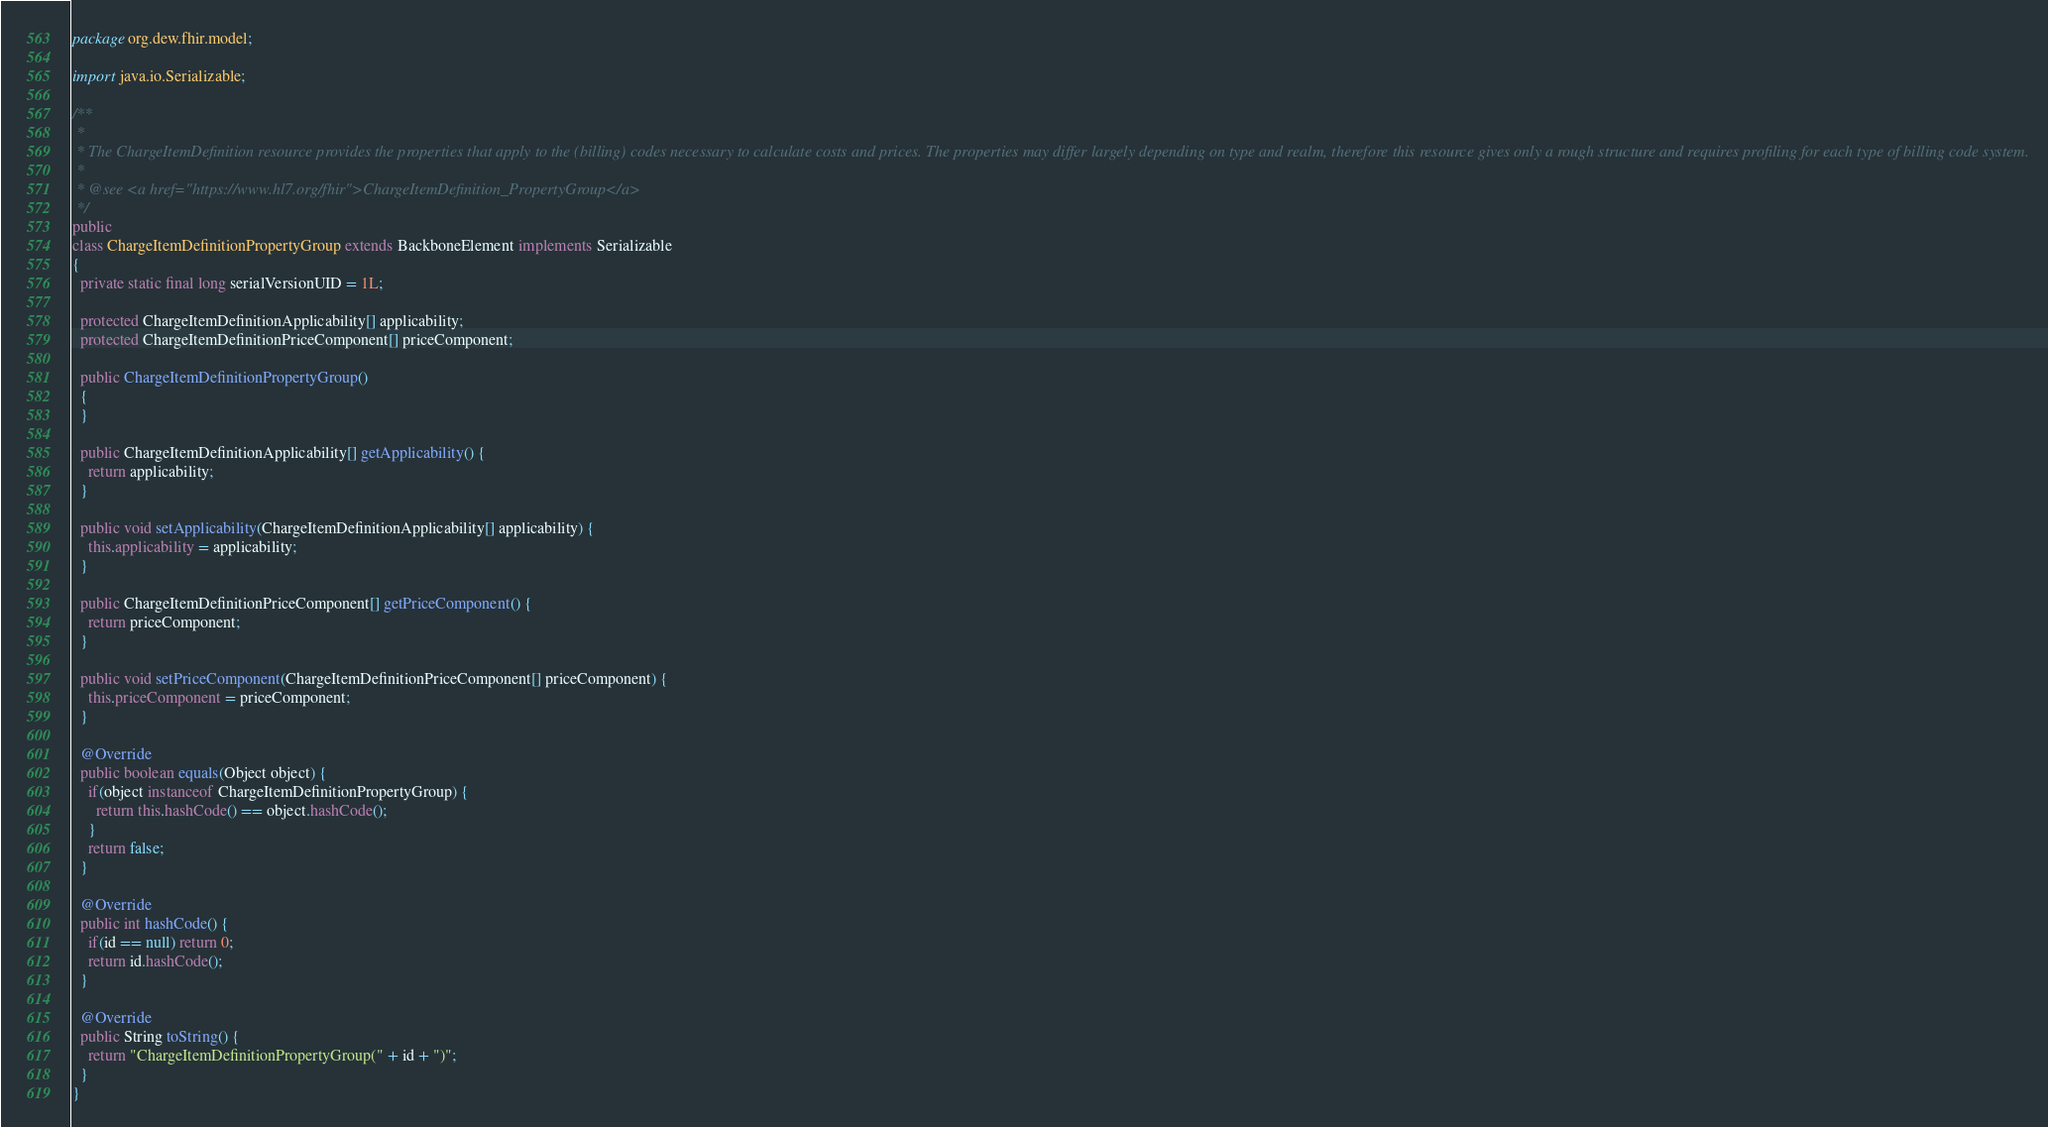<code> <loc_0><loc_0><loc_500><loc_500><_Java_>package org.dew.fhir.model;

import java.io.Serializable;

/**
 *
 * The ChargeItemDefinition resource provides the properties that apply to the (billing) codes necessary to calculate costs and prices. The properties may differ largely depending on type and realm, therefore this resource gives only a rough structure and requires profiling for each type of billing code system.
 *
 * @see <a href="https://www.hl7.org/fhir">ChargeItemDefinition_PropertyGroup</a>
 */
public
class ChargeItemDefinitionPropertyGroup extends BackboneElement implements Serializable
{
  private static final long serialVersionUID = 1L;
  
  protected ChargeItemDefinitionApplicability[] applicability;
  protected ChargeItemDefinitionPriceComponent[] priceComponent;
  
  public ChargeItemDefinitionPropertyGroup()
  {
  }
  
  public ChargeItemDefinitionApplicability[] getApplicability() {
    return applicability;
  }
  
  public void setApplicability(ChargeItemDefinitionApplicability[] applicability) {
    this.applicability = applicability;
  }
  
  public ChargeItemDefinitionPriceComponent[] getPriceComponent() {
    return priceComponent;
  }
  
  public void setPriceComponent(ChargeItemDefinitionPriceComponent[] priceComponent) {
    this.priceComponent = priceComponent;
  }
  
  @Override
  public boolean equals(Object object) {
    if(object instanceof ChargeItemDefinitionPropertyGroup) {
      return this.hashCode() == object.hashCode();
    }
    return false;
  }
  
  @Override
  public int hashCode() {
    if(id == null) return 0;
    return id.hashCode();
  }
  
  @Override
  public String toString() {
    return "ChargeItemDefinitionPropertyGroup(" + id + ")";
  }
}
</code> 